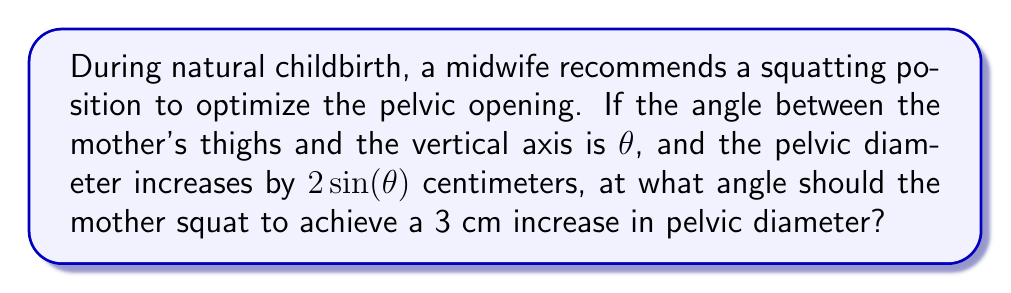Teach me how to tackle this problem. Let's approach this step-by-step:

1) We're given that the pelvic diameter increase is $2\sin(\theta)$ cm, where $\theta$ is the angle between the mother's thighs and the vertical axis.

2) We want this increase to be 3 cm. So we can set up the equation:

   $$2\sin(\theta) = 3$$

3) To solve for $\theta$, we first divide both sides by 2:

   $$\sin(\theta) = \frac{3}{2}$$

4) Now, we need to take the inverse sine (arcsin) of both sides:

   $$\theta = \arcsin(\frac{3}{2})$$

5) However, we need to check if this is possible. The sine function is only defined between -1 and 1. In this case, $\frac{3}{2} > 1$, so there's no real solution.

6) This means that it's not possible to achieve exactly 3 cm increase with this model. The maximum increase would be 2 cm when $\theta = 90°$ (as $\sin(90°) = 1$).

7) Therefore, the optimal angle for the maximum possible increase is 90°.

[asy]
import geometry;

size(200);
draw((-1,0)--(1,0),arrow=Arrow(TeXHead));
draw((0,-1)--(0,1),arrow=Arrow(TeXHead));
draw((0,0)--(0.707,0.707),arrow=Arrow(TeXHead));
label("90°",(0.2,0.2));
label("θ",(0.4,0.4));
[/asy]
Answer: 90° 